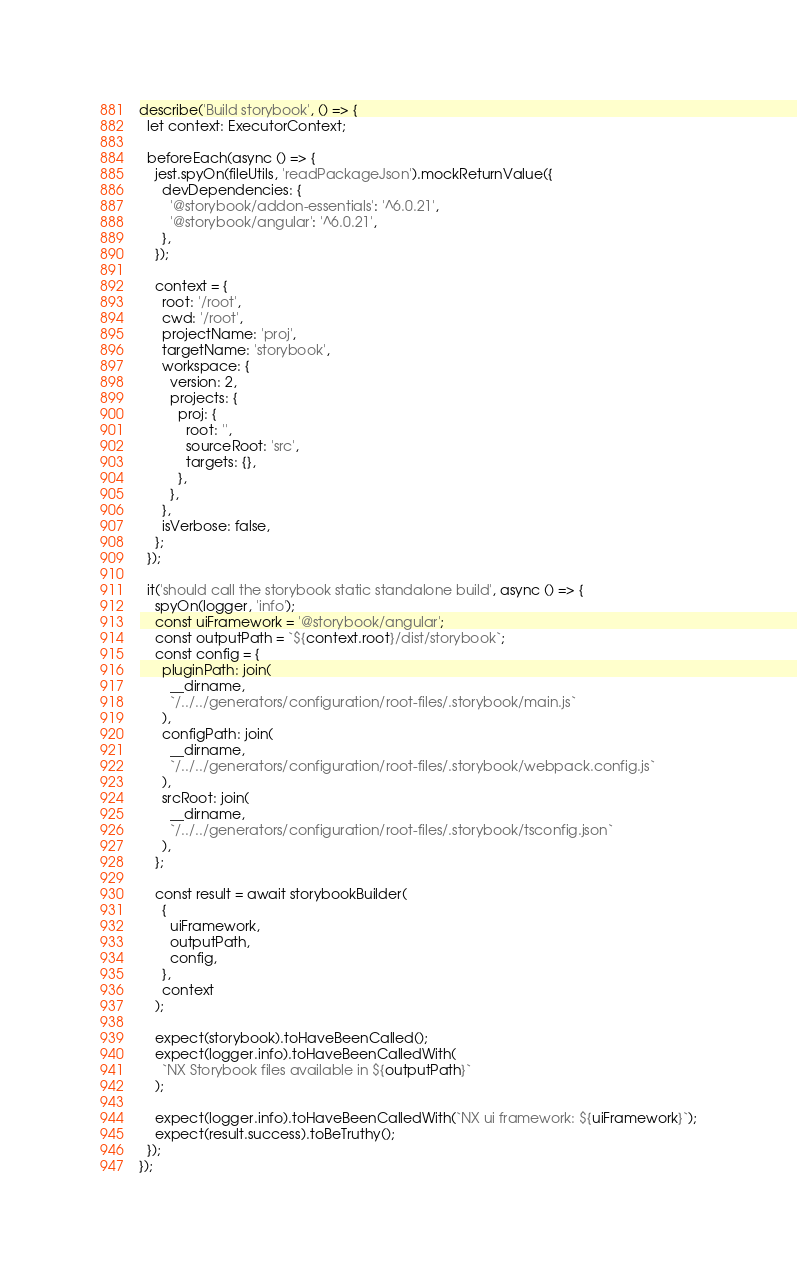Convert code to text. <code><loc_0><loc_0><loc_500><loc_500><_TypeScript_>describe('Build storybook', () => {
  let context: ExecutorContext;

  beforeEach(async () => {
    jest.spyOn(fileUtils, 'readPackageJson').mockReturnValue({
      devDependencies: {
        '@storybook/addon-essentials': '^6.0.21',
        '@storybook/angular': '^6.0.21',
      },
    });

    context = {
      root: '/root',
      cwd: '/root',
      projectName: 'proj',
      targetName: 'storybook',
      workspace: {
        version: 2,
        projects: {
          proj: {
            root: '',
            sourceRoot: 'src',
            targets: {},
          },
        },
      },
      isVerbose: false,
    };
  });

  it('should call the storybook static standalone build', async () => {
    spyOn(logger, 'info');
    const uiFramework = '@storybook/angular';
    const outputPath = `${context.root}/dist/storybook`;
    const config = {
      pluginPath: join(
        __dirname,
        `/../../generators/configuration/root-files/.storybook/main.js`
      ),
      configPath: join(
        __dirname,
        `/../../generators/configuration/root-files/.storybook/webpack.config.js`
      ),
      srcRoot: join(
        __dirname,
        `/../../generators/configuration/root-files/.storybook/tsconfig.json`
      ),
    };

    const result = await storybookBuilder(
      {
        uiFramework,
        outputPath,
        config,
      },
      context
    );

    expect(storybook).toHaveBeenCalled();
    expect(logger.info).toHaveBeenCalledWith(
      `NX Storybook files available in ${outputPath}`
    );

    expect(logger.info).toHaveBeenCalledWith(`NX ui framework: ${uiFramework}`);
    expect(result.success).toBeTruthy();
  });
});
</code> 